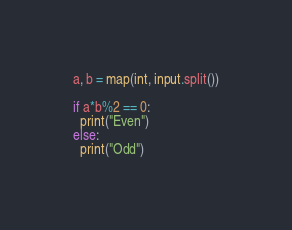<code> <loc_0><loc_0><loc_500><loc_500><_Python_>a, b = map(int, input.split())

if a*b%2 == 0:
  print("Even")
else:
  print("Odd")</code> 